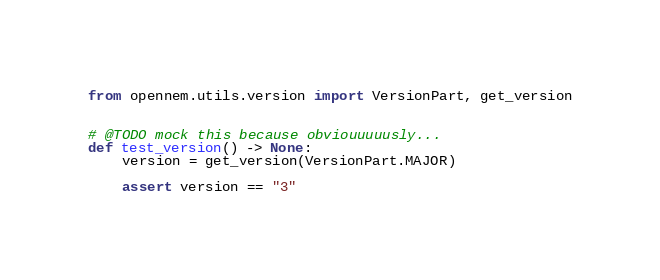<code> <loc_0><loc_0><loc_500><loc_500><_Python_>from opennem.utils.version import VersionPart, get_version


# @TODO mock this because obviouuuuusly...
def test_version() -> None:
    version = get_version(VersionPart.MAJOR)

    assert version == "3"
</code> 